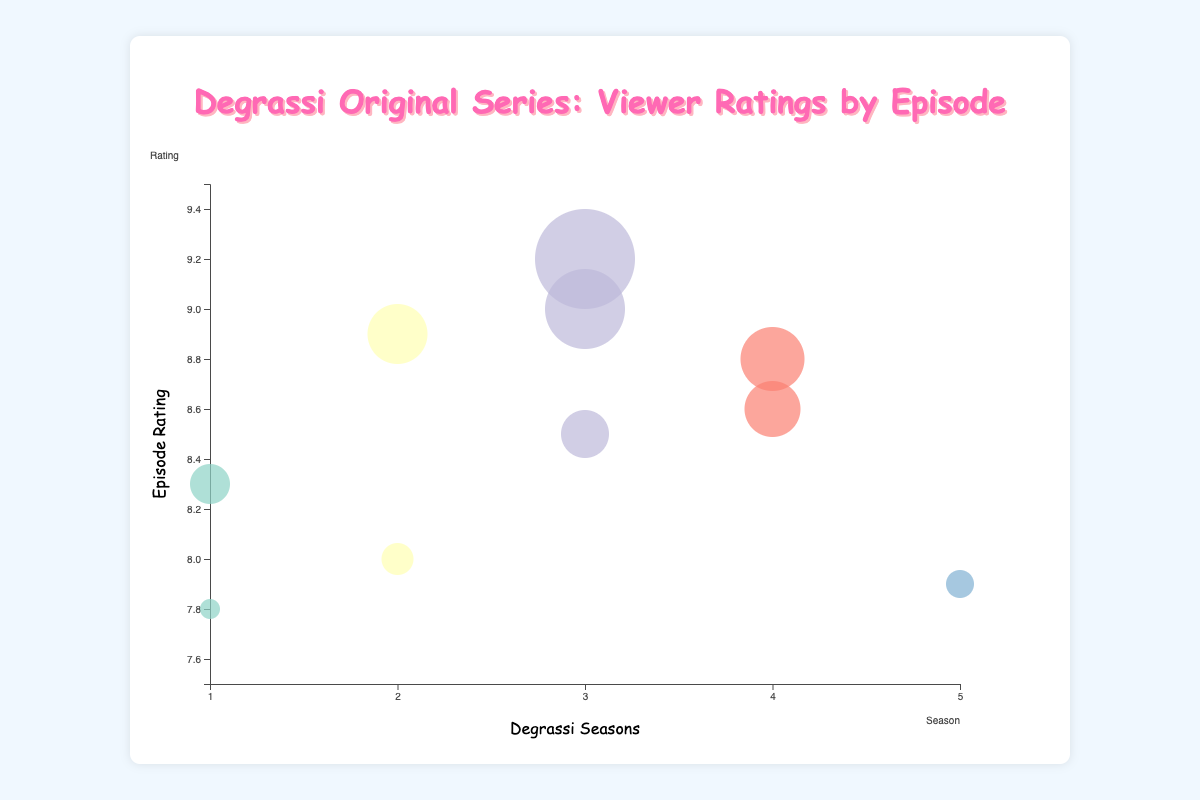Which episode has the highest rating? Look for the bubble representing the highest vertical position on the chart. The bubble with the highest rating is "Bye-Bye Junior High" in Season 3, with a rating of 9.2.
Answer: "Bye-Bye Junior High" How many episodes have a viewership of 1.5 million? Identify the bubbles with the specified viewership positioned horizontally. The episodes with a viewership of 1.5 million are "Rumor Has It" in Season 2 and "Everybody Wants Something" in Season 4.
Answer: 2 Which episode has the largest bubble size and what does this indicate? The largest bubble corresponds to both viewership and importance. The episode with the largest bubble is "Bye-Bye Junior High" in Season 3, which has a bubble size of 45, indicating it has high viewership and significance.
Answer: "Bye-Bye Junior High" What is the average rating of episodes in Season 1? Verify the ratings of the episodes in Season 1: 8.3 for "Kiss Me, Steph" and 7.8 for "The Big Dance". Calculate the average: (8.3 + 7.8) / 2 = 8.05.
Answer: 8.05 Compare the viewership between the episodes "Taking Off: Part 1" and "Taking Off: Part 2". Which one had higher viewership? Locate both episodes on the chart. "Taking Off: Part 1" has a viewership of 1.4 million while "Taking Off: Part 2" has a viewership of 1.6 million. Therefore, "Taking Off: Part 2" had higher viewership.
Answer: "Taking Off: Part 2" What is the total viewership of all episodes in Season 3? Sum up the viewership numbers of episodes from Season 3: 1.4 million ("Taking Off: Part 1"), 1.6 million ("Taking Off: Part 2"), and 1.7 million ("Bye-Bye Junior High"): 1.4 + 1.6 + 1.7 = 4.7 million.
Answer: 4.7 million Arrange the ratings for Season 2 from highest to lowest. Identify and list the ratings for Season 2: "Rumor Has It" has 8.9, and "Fight!" has 8.0. Arrange them as: 8.9, 8.0.
Answer: 8.9, 8.0 How do ratings correlate with bubble sizes? Observe the vertical position and size of the bubbles. Higher bubble sizes generally correspond with higher ratings, indicating a positive correlation. For example, "Bye-Bye Junior High" has the highest rating (9.2) and the largest bubble size (45).
Answer: Positive correlation What is the range of viewership values for the episodes? Identify the minimum and maximum values of viewership from the data set: "The Big Dance" has the minimum viewership of 1.1 million, and "Bye-Bye Junior High" has the maximum viewership of 1.7 million. The range is 1.7 - 1.1 = 0.6 million.
Answer: 0.6 million 